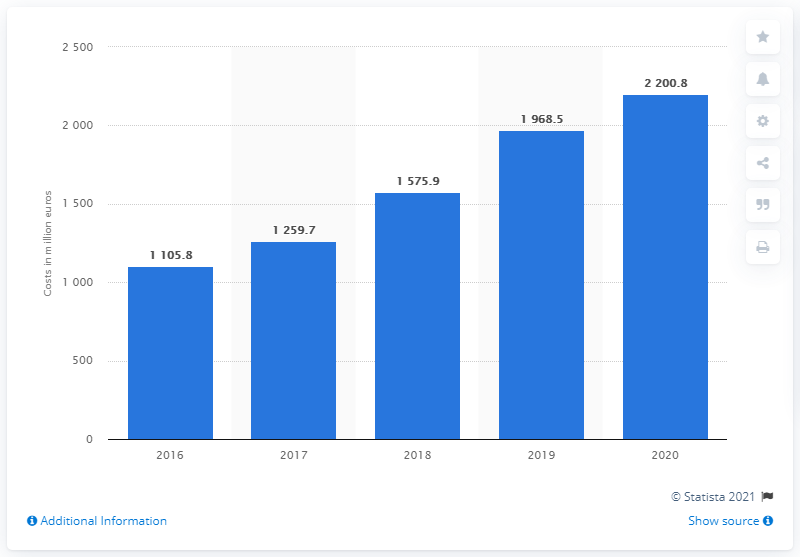Mention a couple of crucial points in this snapshot. ASML invested the most in research and development in the year 2020. In 2020, ASML invested 2,200.8 million in research and development. ASML's R&D investments in the previous year were 1968.5.. 